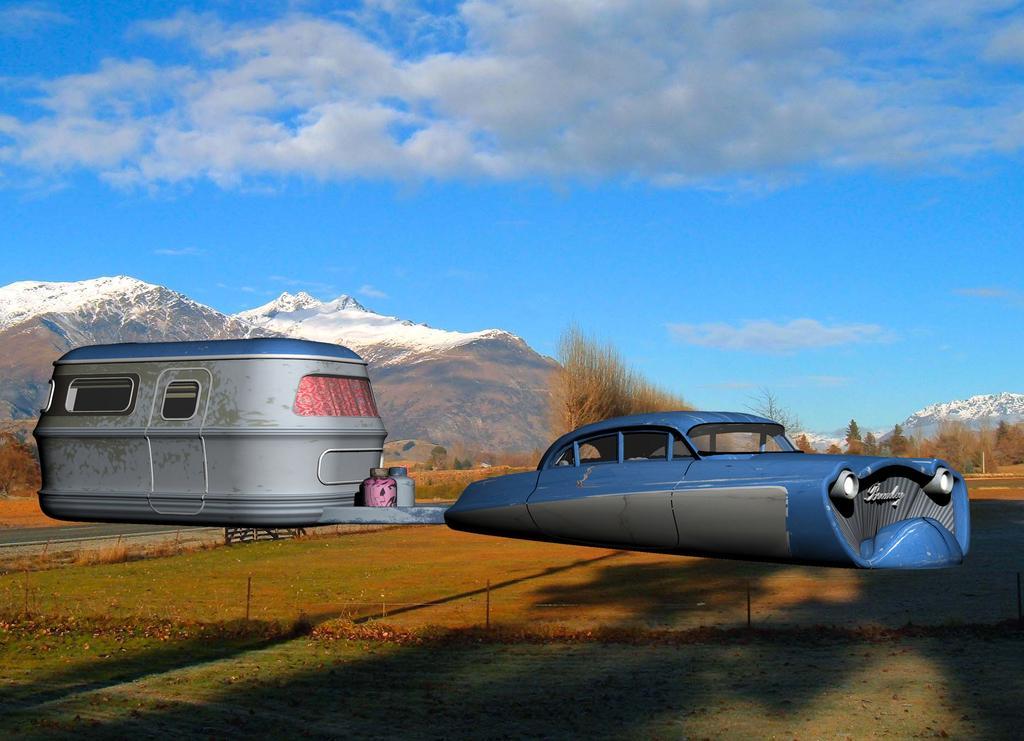In one or two sentences, can you explain what this image depicts? In this picture I can see the car and van. in the background I can see the snow mountains. At the top I can see the sky and clouds. 